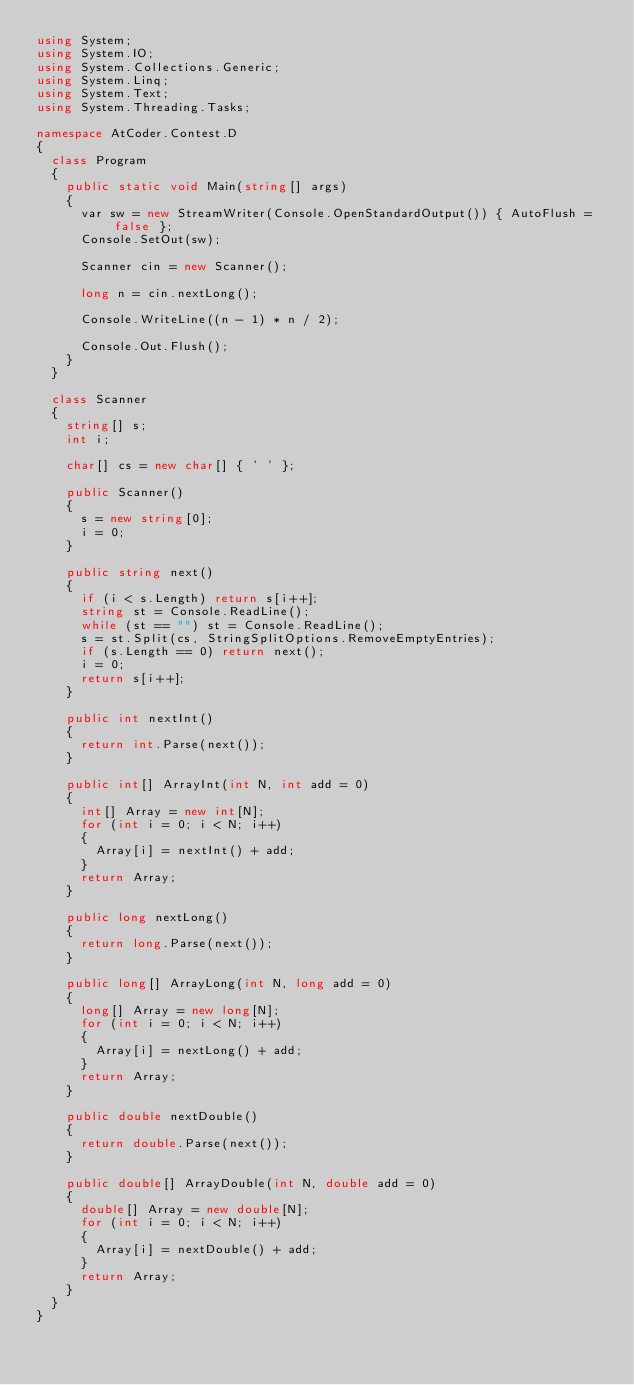Convert code to text. <code><loc_0><loc_0><loc_500><loc_500><_C#_>using System;
using System.IO;
using System.Collections.Generic;
using System.Linq;
using System.Text;
using System.Threading.Tasks;

namespace AtCoder.Contest.D
{
	class Program
	{
		public static void Main(string[] args)
		{
			var sw = new StreamWriter(Console.OpenStandardOutput()) { AutoFlush = false };
			Console.SetOut(sw);

			Scanner cin = new Scanner();

			long n = cin.nextLong();

			Console.WriteLine((n - 1) * n / 2);

			Console.Out.Flush();
		}
	}

	class Scanner
	{
		string[] s;
		int i;

		char[] cs = new char[] { ' ' };

		public Scanner()
		{
			s = new string[0];
			i = 0;
		}

		public string next()
		{
			if (i < s.Length) return s[i++];
			string st = Console.ReadLine();
			while (st == "") st = Console.ReadLine();
			s = st.Split(cs, StringSplitOptions.RemoveEmptyEntries);
			if (s.Length == 0) return next();
			i = 0;
			return s[i++];
		}

		public int nextInt()
		{
			return int.Parse(next());
		}

		public int[] ArrayInt(int N, int add = 0)
		{
			int[] Array = new int[N];
			for (int i = 0; i < N; i++)
			{
				Array[i] = nextInt() + add;
			}
			return Array;
		}

		public long nextLong()
		{
			return long.Parse(next());
		}

		public long[] ArrayLong(int N, long add = 0)
		{
			long[] Array = new long[N];
			for (int i = 0; i < N; i++)
			{
				Array[i] = nextLong() + add;
			}
			return Array;
		}

		public double nextDouble()
		{
			return double.Parse(next());
		}

		public double[] ArrayDouble(int N, double add = 0)
		{
			double[] Array = new double[N];
			for (int i = 0; i < N; i++)
			{
				Array[i] = nextDouble() + add;
			}
			return Array;
		}
	}
}</code> 